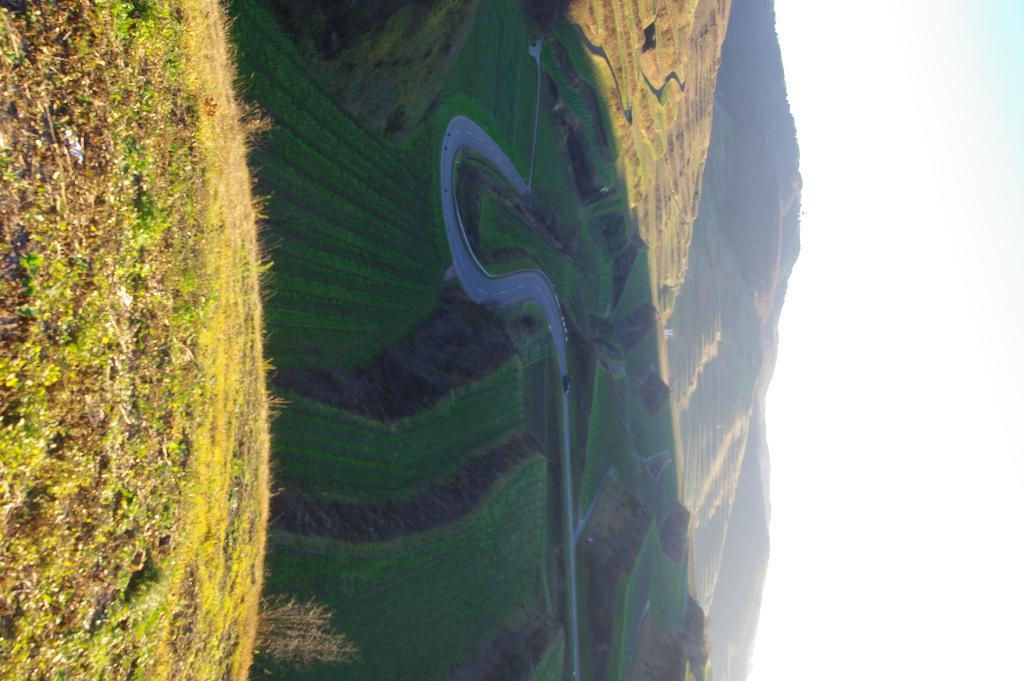What type of vegetation is present on the left side of the image? There is grass on the ground on the left side of the image. What can be seen in the distance in the image? There is a road visible in the background of the image. What other vegetation is present in the image? There is grass in the background of the image. What geographical features are visible in the background of the image? There are hills in the background of the image. What is visible in the sky in the background of the image? There are clouds in the sky in the background of the image. What type of lamp is hanging from the wing of the bird in the image? There is no lamp or bird present in the image; it features grass, a road, hills, and clouds. 